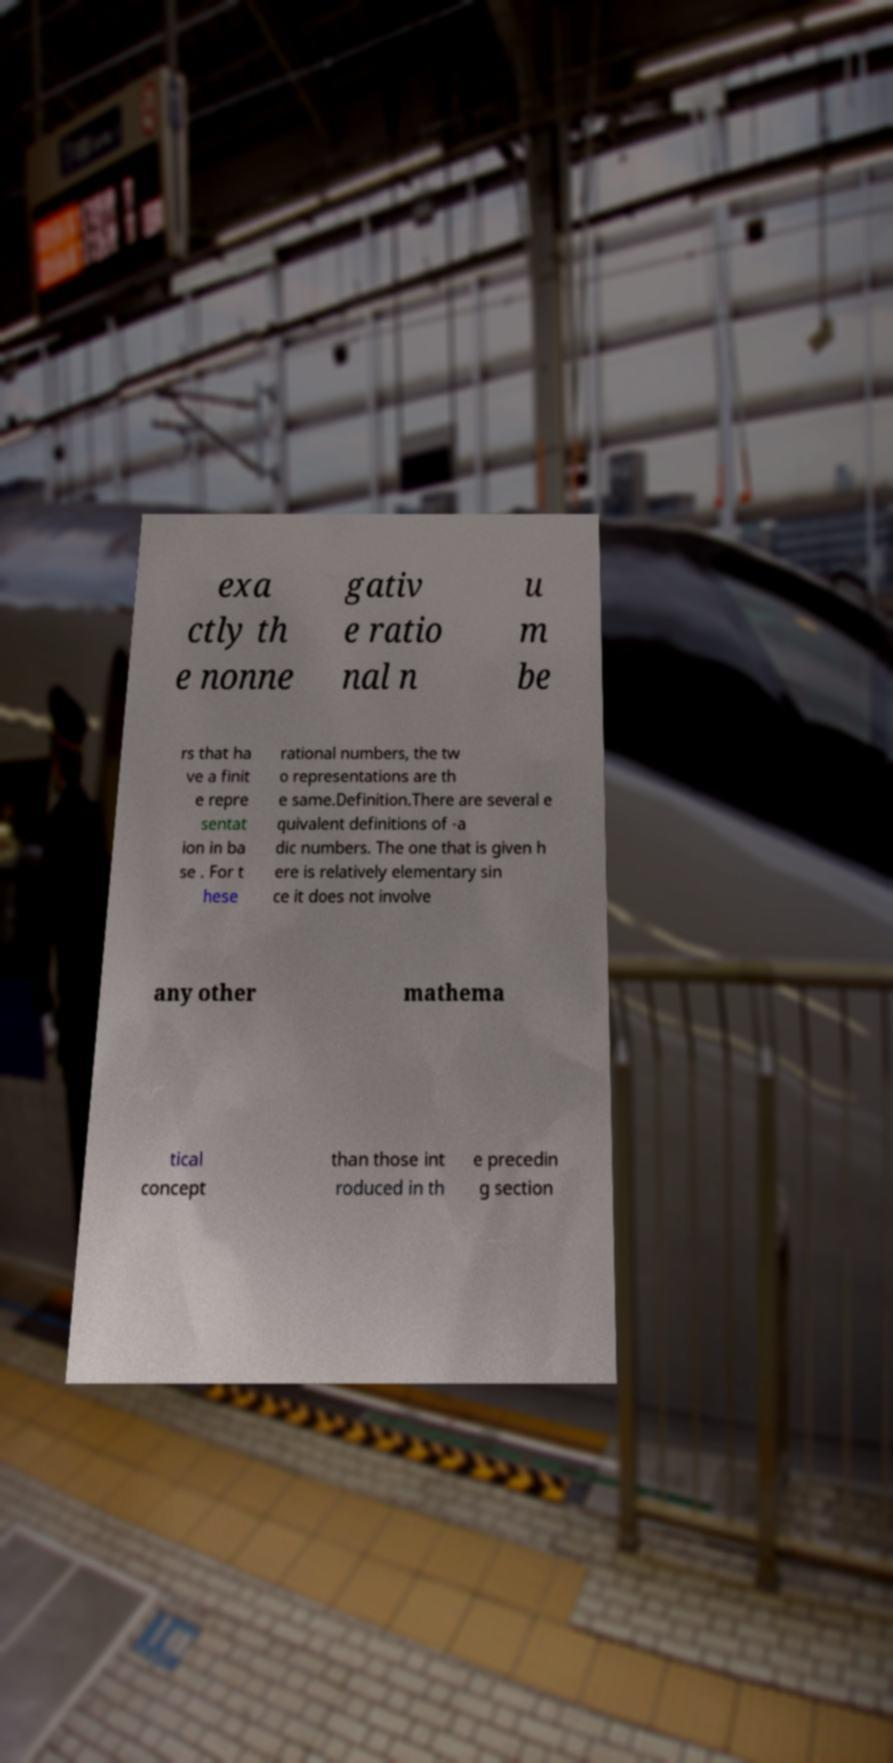Could you extract and type out the text from this image? exa ctly th e nonne gativ e ratio nal n u m be rs that ha ve a finit e repre sentat ion in ba se . For t hese rational numbers, the tw o representations are th e same.Definition.There are several e quivalent definitions of -a dic numbers. The one that is given h ere is relatively elementary sin ce it does not involve any other mathema tical concept than those int roduced in th e precedin g section 